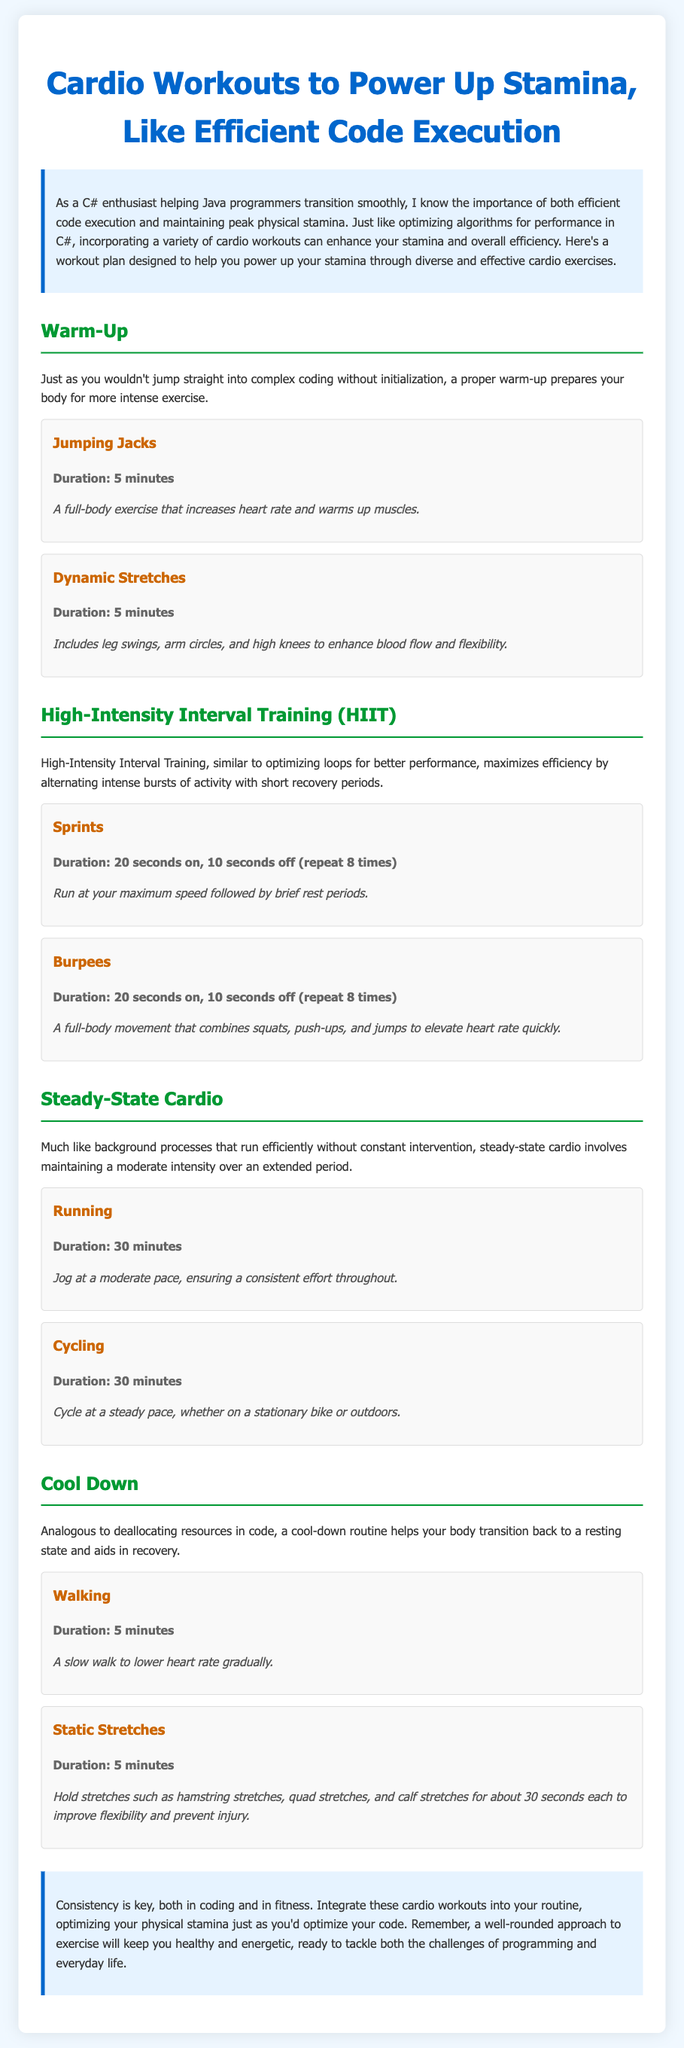What is the title of the document? The title is located at the top of the document and summarizes the content.
Answer: Cardio Workouts to Power Up Stamina, Like Efficient Code Execution How long should you perform Jumping Jacks? The duration for Jumping Jacks is specified under the exercise section in the document.
Answer: 5 minutes What type of training is described as alternating bursts of activity? The document explains a type of training that maximizes efficiency and involves alternating between different intensities.
Answer: High-Intensity Interval Training (HIIT) What exercise is recommended for the cool-down phase? The cool-down phase includes specific exercises aimed at recovery.
Answer: Walking How many times should sprints be repeated in HIIT? The document states a specific number of repetitions for the sprint exercise in the HIIT section.
Answer: 8 times What is the duration for the steady-state cardio exercise 'Running'? The duration for this exercise is clearly outlined in the steady-state cardio section.
Answer: 30 minutes What is the main objective of the workout plan? The objective is defined in the introductory paragraph, emphasizing stamina and efficiency.
Answer: Power up your stamina What is a recommended duration for static stretches? The document specifies how long to hold certain stretches in the cool-down section.
Answer: 5 minutes 